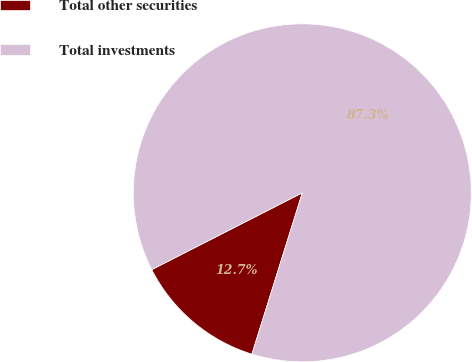Convert chart. <chart><loc_0><loc_0><loc_500><loc_500><pie_chart><fcel>Total other securities<fcel>Total investments<nl><fcel>12.67%<fcel>87.33%<nl></chart> 